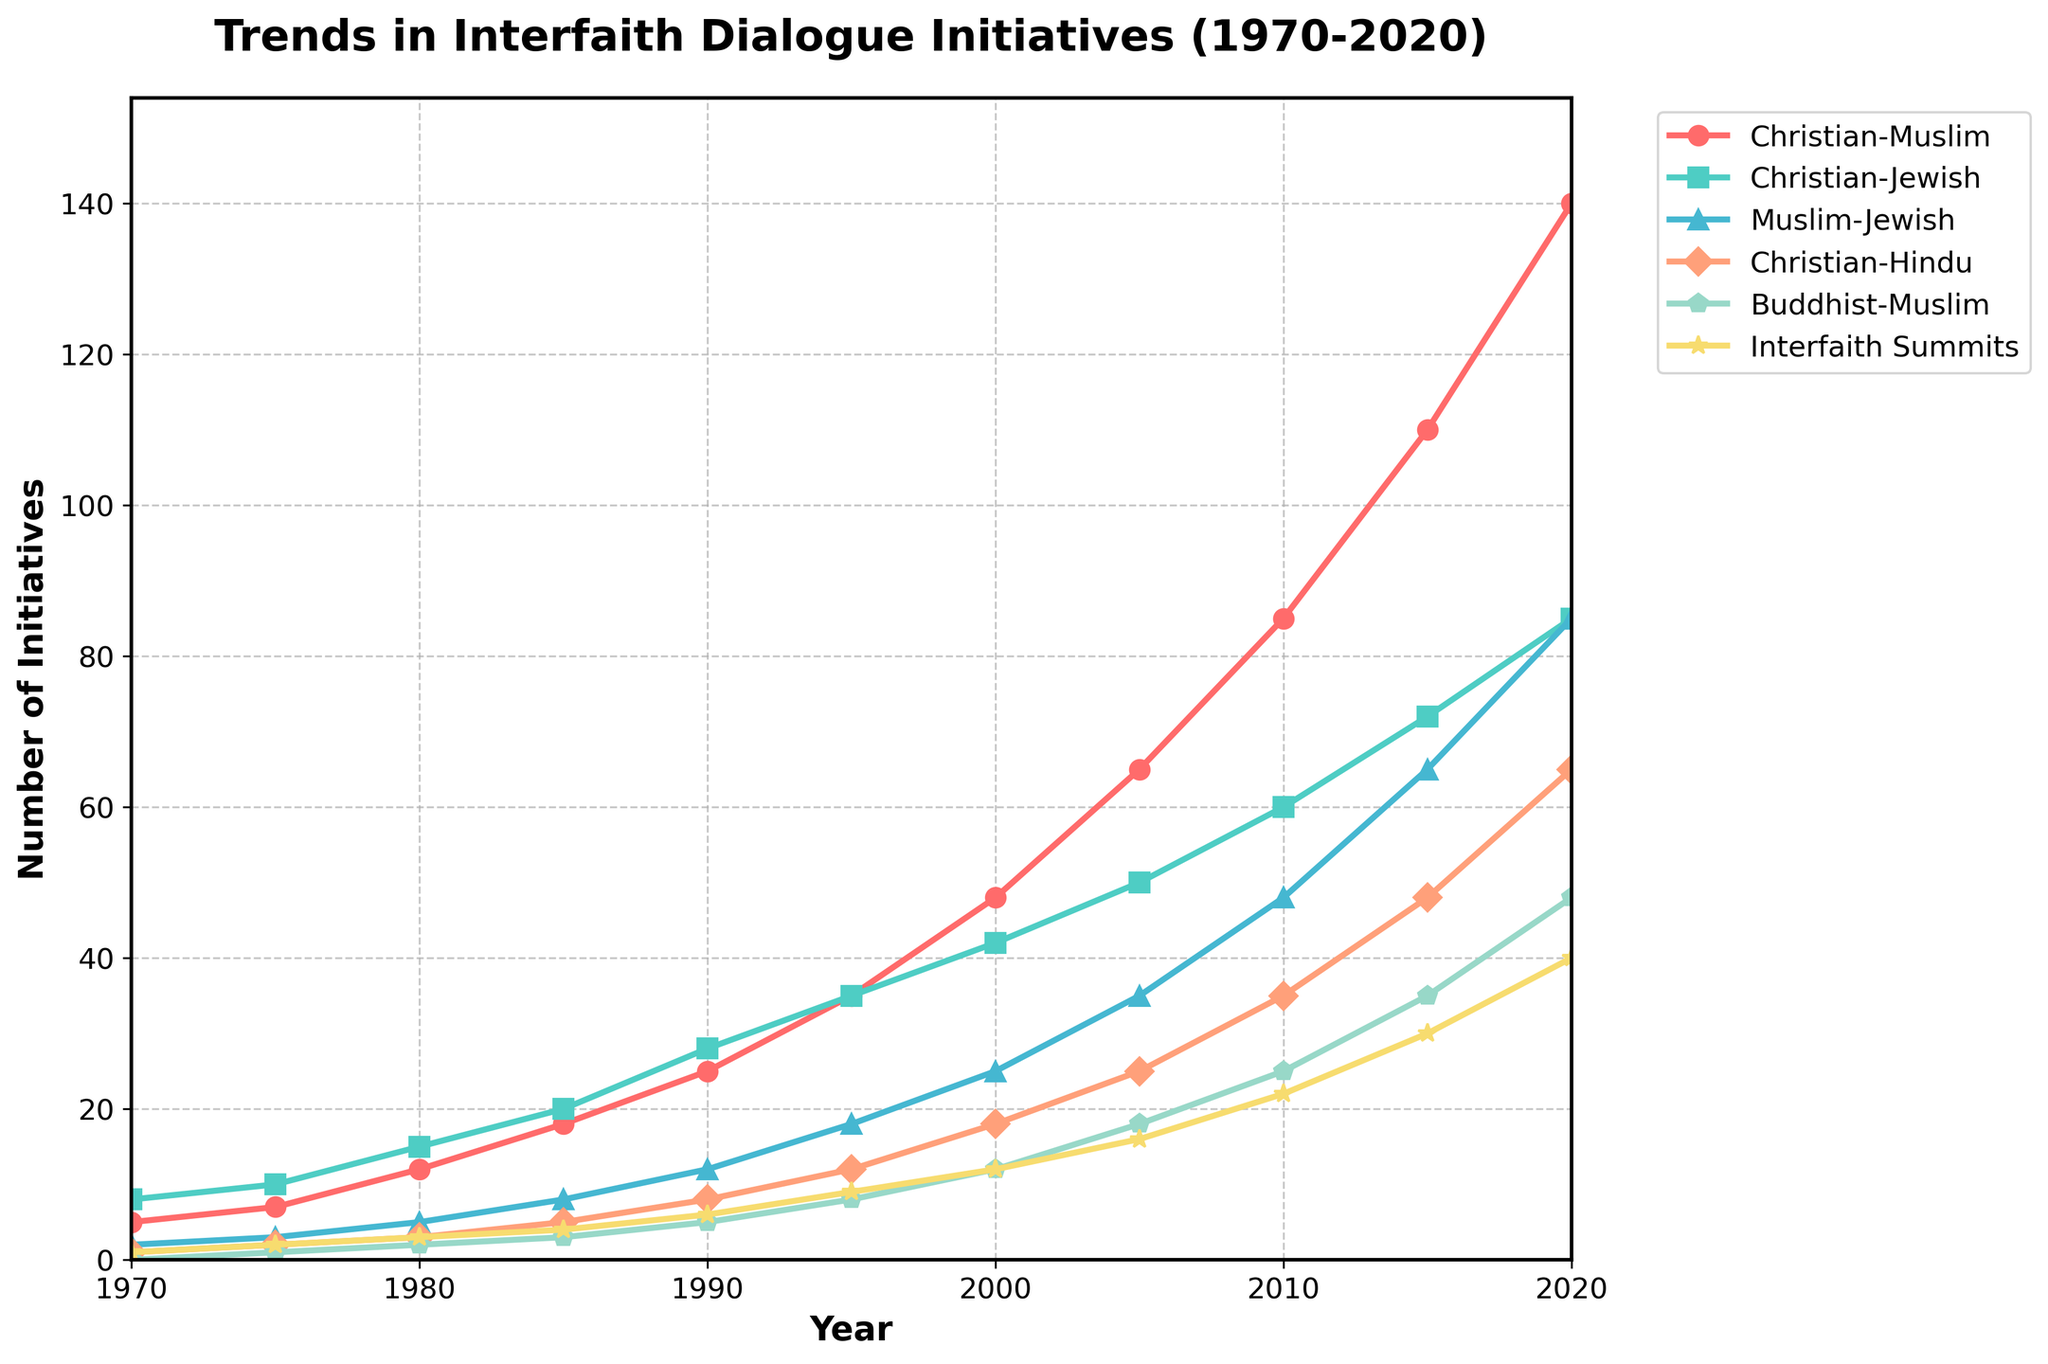What is the overall trend in the number of Christian-Muslim dialogue initiatives from 1970 to 2020? By analyzing the plot, we can see that the number of Christian-Muslim dialogue initiatives has steadily increased over the 50 years, starting from 5 initiatives in 1970 and rising to 140 initiatives in 2020.
Answer: Steady increase Which interfaith dialogue category saw the highest growth over the period? By inspecting the plot, it is evident that the category of Christian-Muslim dialogue initiatives has the highest end value in 2020 (140 initiatives), indicating the greatest growth over the period compared to other categories.
Answer: Christian-Muslim In what year did Interfaith Summits equal the number of Muslim-Jewish initiatives? Looking at the plot, we can see that in 2015 both the Interfaith Summits and Muslim-Jewish initiatives reached 30 initiatives.
Answer: 2015 What is the difference in the number of Christian-Hindu initiatives between 1980 and 2010? Referring to the plot, the number of Christian-Hindu initiatives in 1980 was 3 and in 2010 it was 35. The difference is calculated by subtracting the 1980 value from the 2010 value: 35 - 3 = 32.
Answer: 32 Which dialogue initiative category was initiated the most frequently in 1975? Checking the plot for the year 1975, the Christian-Jewish dialogue category had the most initiatives with 10.
Answer: Christian-Jewish How does the number of Buddhist-Muslim initiatives in 2020 compare to that in 1975? From the plot, the number of Buddhist-Muslim initiatives in 1975 was 1, and in 2020 it was 48. Comparing these values shows a significant increase from 1975 to 2020.
Answer: Increased significantly What was the average number of Christian-Muslim initiatives from 1970 to 1995? To find the average, first sum the number of Christian-Muslim initiatives from 1970 to 1995 (5, 7, 12, 18, 25, 35). The sum is 102, and there are 6 data points, so the average is 102 / 6 = 17.
Answer: 17 Which year showed the highest single-year increase in the number of Christian-Muslim initiatives? Observing the year-to-year changes in the plot, the highest single-year increase in Christian-Muslim initiatives occurred between 2015 and 2020, where the increase was from 110 to 140, a rise of 30 initiatives.
Answer: 2015-2020 How many more initiatives of all types were there in 2020 compared to 1980? Summing up all the initiatives in 2020 (140 + 85 + 85 + 65 + 48 + 40) results in 463, and in 1980 (12 + 15 + 5 + 3 + 2 + 3) results in 40. The difference is 463 - 40 = 423.
Answer: 423 What is the most common color associated with the highest counted initiative category? The plot shows the color red is associated with the Christian-Muslim category, which has the highest number of initiatives.
Answer: Red 